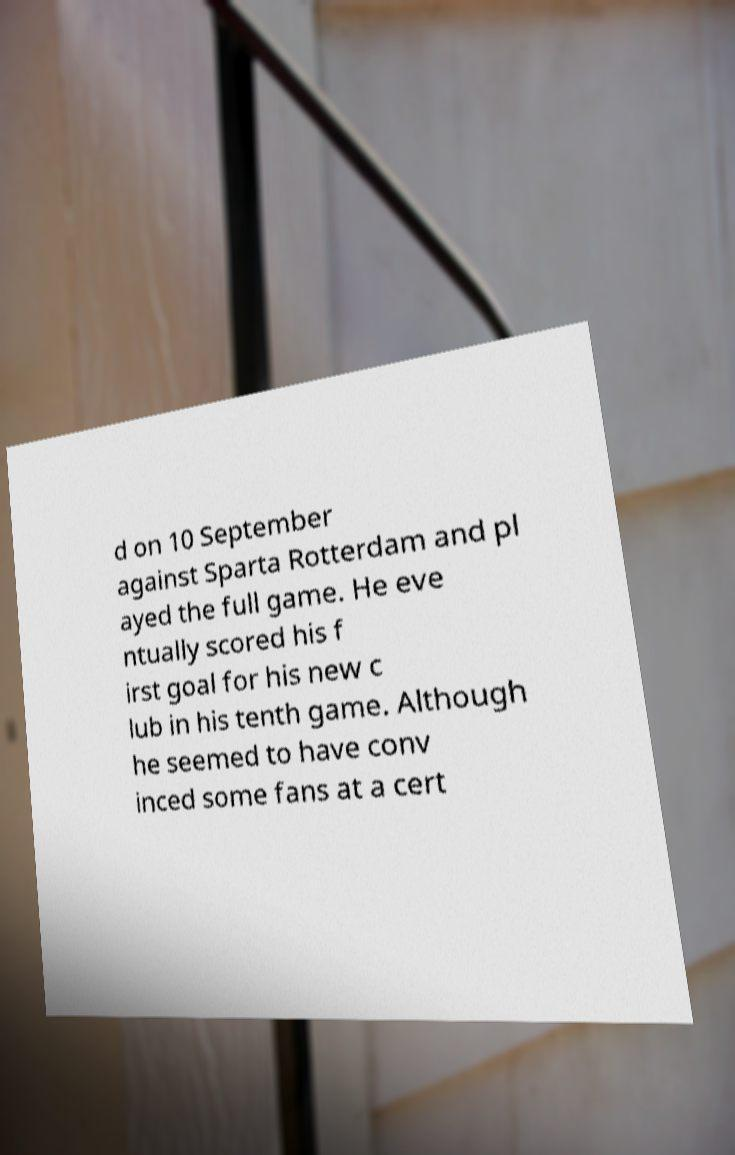What messages or text are displayed in this image? I need them in a readable, typed format. d on 10 September against Sparta Rotterdam and pl ayed the full game. He eve ntually scored his f irst goal for his new c lub in his tenth game. Although he seemed to have conv inced some fans at a cert 